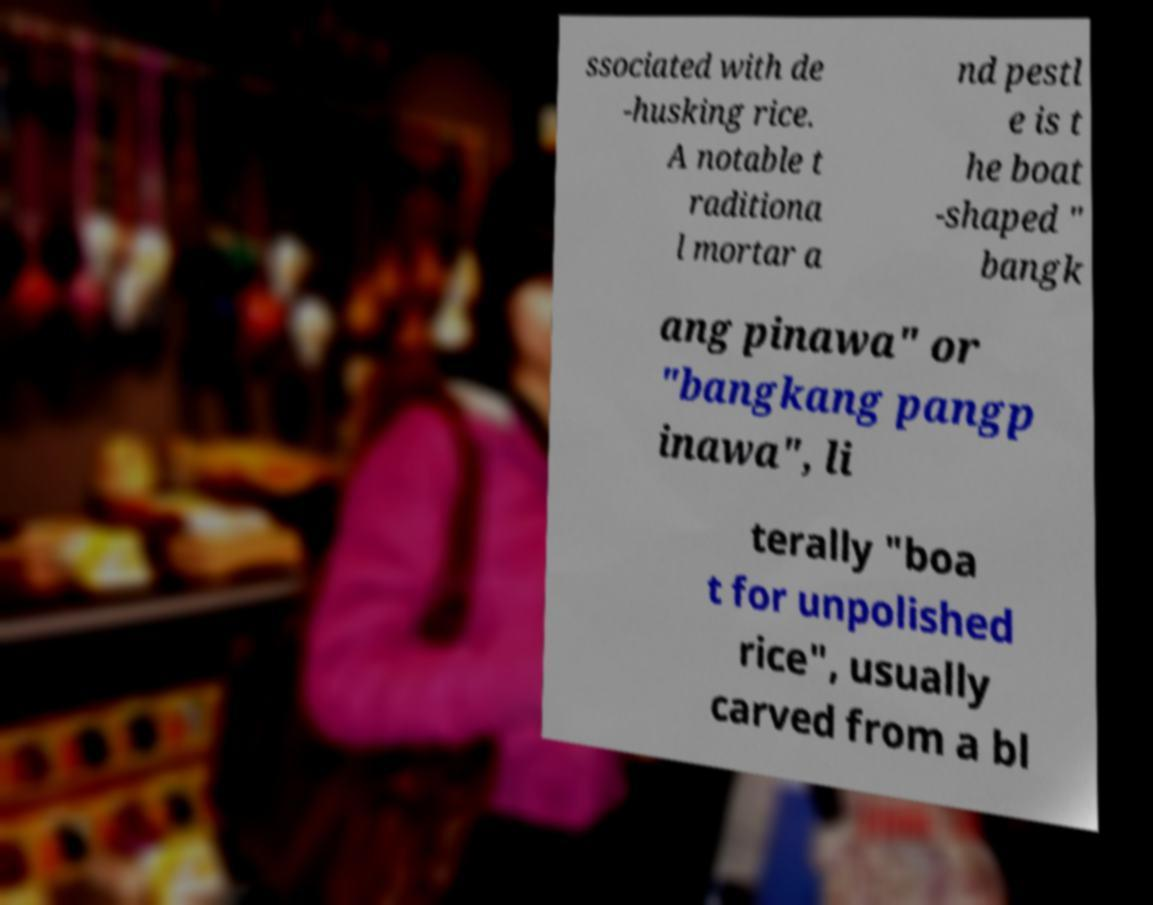Can you accurately transcribe the text from the provided image for me? ssociated with de -husking rice. A notable t raditiona l mortar a nd pestl e is t he boat -shaped " bangk ang pinawa" or "bangkang pangp inawa", li terally "boa t for unpolished rice", usually carved from a bl 